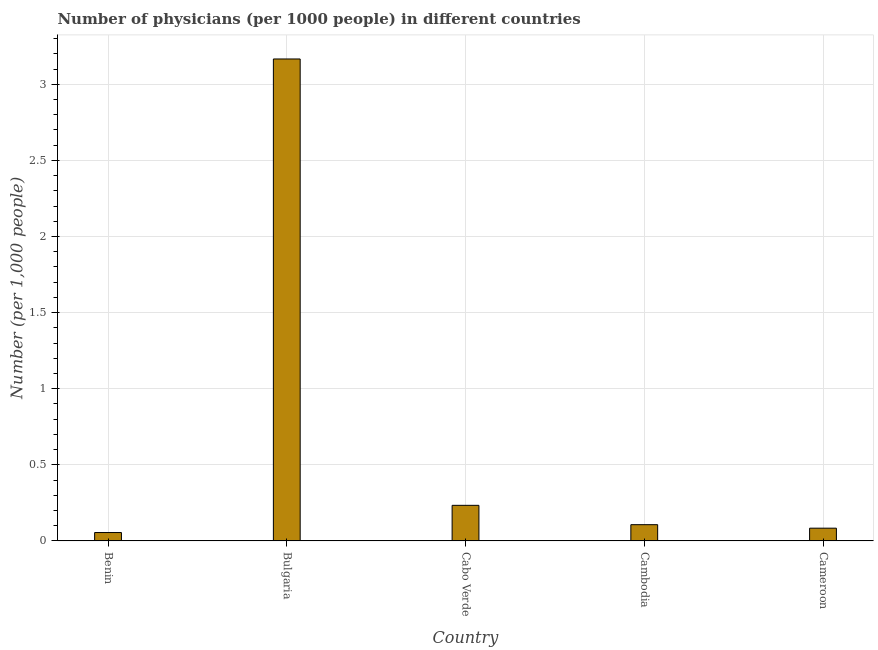Does the graph contain any zero values?
Keep it short and to the point. No. What is the title of the graph?
Give a very brief answer. Number of physicians (per 1000 people) in different countries. What is the label or title of the Y-axis?
Your answer should be very brief. Number (per 1,0 people). What is the number of physicians in Benin?
Your answer should be compact. 0.06. Across all countries, what is the maximum number of physicians?
Make the answer very short. 3.17. Across all countries, what is the minimum number of physicians?
Offer a terse response. 0.06. In which country was the number of physicians minimum?
Offer a very short reply. Benin. What is the sum of the number of physicians?
Provide a short and direct response. 3.65. What is the difference between the number of physicians in Bulgaria and Cameroon?
Ensure brevity in your answer.  3.08. What is the average number of physicians per country?
Your response must be concise. 0.73. What is the median number of physicians?
Your answer should be compact. 0.11. What is the ratio of the number of physicians in Benin to that in Bulgaria?
Your response must be concise. 0.02. Is the number of physicians in Bulgaria less than that in Cabo Verde?
Offer a very short reply. No. Is the difference between the number of physicians in Benin and Cabo Verde greater than the difference between any two countries?
Your answer should be compact. No. What is the difference between the highest and the second highest number of physicians?
Your answer should be compact. 2.93. Is the sum of the number of physicians in Cabo Verde and Cameroon greater than the maximum number of physicians across all countries?
Make the answer very short. No. What is the difference between the highest and the lowest number of physicians?
Provide a succinct answer. 3.11. In how many countries, is the number of physicians greater than the average number of physicians taken over all countries?
Your answer should be compact. 1. Are all the bars in the graph horizontal?
Ensure brevity in your answer.  No. What is the difference between two consecutive major ticks on the Y-axis?
Your answer should be compact. 0.5. Are the values on the major ticks of Y-axis written in scientific E-notation?
Provide a short and direct response. No. What is the Number (per 1,000 people) of Benin?
Offer a very short reply. 0.06. What is the Number (per 1,000 people) in Bulgaria?
Your answer should be compact. 3.17. What is the Number (per 1,000 people) in Cabo Verde?
Give a very brief answer. 0.23. What is the Number (per 1,000 people) in Cambodia?
Your answer should be compact. 0.11. What is the Number (per 1,000 people) of Cameroon?
Ensure brevity in your answer.  0.08. What is the difference between the Number (per 1,000 people) in Benin and Bulgaria?
Provide a short and direct response. -3.11. What is the difference between the Number (per 1,000 people) in Benin and Cabo Verde?
Offer a very short reply. -0.18. What is the difference between the Number (per 1,000 people) in Benin and Cambodia?
Provide a succinct answer. -0.05. What is the difference between the Number (per 1,000 people) in Benin and Cameroon?
Ensure brevity in your answer.  -0.03. What is the difference between the Number (per 1,000 people) in Bulgaria and Cabo Verde?
Your answer should be compact. 2.93. What is the difference between the Number (per 1,000 people) in Bulgaria and Cambodia?
Ensure brevity in your answer.  3.06. What is the difference between the Number (per 1,000 people) in Bulgaria and Cameroon?
Your answer should be compact. 3.08. What is the difference between the Number (per 1,000 people) in Cabo Verde and Cambodia?
Give a very brief answer. 0.13. What is the difference between the Number (per 1,000 people) in Cabo Verde and Cameroon?
Make the answer very short. 0.15. What is the difference between the Number (per 1,000 people) in Cambodia and Cameroon?
Your response must be concise. 0.02. What is the ratio of the Number (per 1,000 people) in Benin to that in Bulgaria?
Ensure brevity in your answer.  0.02. What is the ratio of the Number (per 1,000 people) in Benin to that in Cabo Verde?
Your answer should be compact. 0.24. What is the ratio of the Number (per 1,000 people) in Benin to that in Cambodia?
Your answer should be very brief. 0.52. What is the ratio of the Number (per 1,000 people) in Benin to that in Cameroon?
Provide a succinct answer. 0.66. What is the ratio of the Number (per 1,000 people) in Bulgaria to that in Cabo Verde?
Make the answer very short. 13.54. What is the ratio of the Number (per 1,000 people) in Bulgaria to that in Cambodia?
Your response must be concise. 29.67. What is the ratio of the Number (per 1,000 people) in Bulgaria to that in Cameroon?
Keep it short and to the point. 37.83. What is the ratio of the Number (per 1,000 people) in Cabo Verde to that in Cambodia?
Keep it short and to the point. 2.19. What is the ratio of the Number (per 1,000 people) in Cabo Verde to that in Cameroon?
Give a very brief answer. 2.79. What is the ratio of the Number (per 1,000 people) in Cambodia to that in Cameroon?
Make the answer very short. 1.27. 